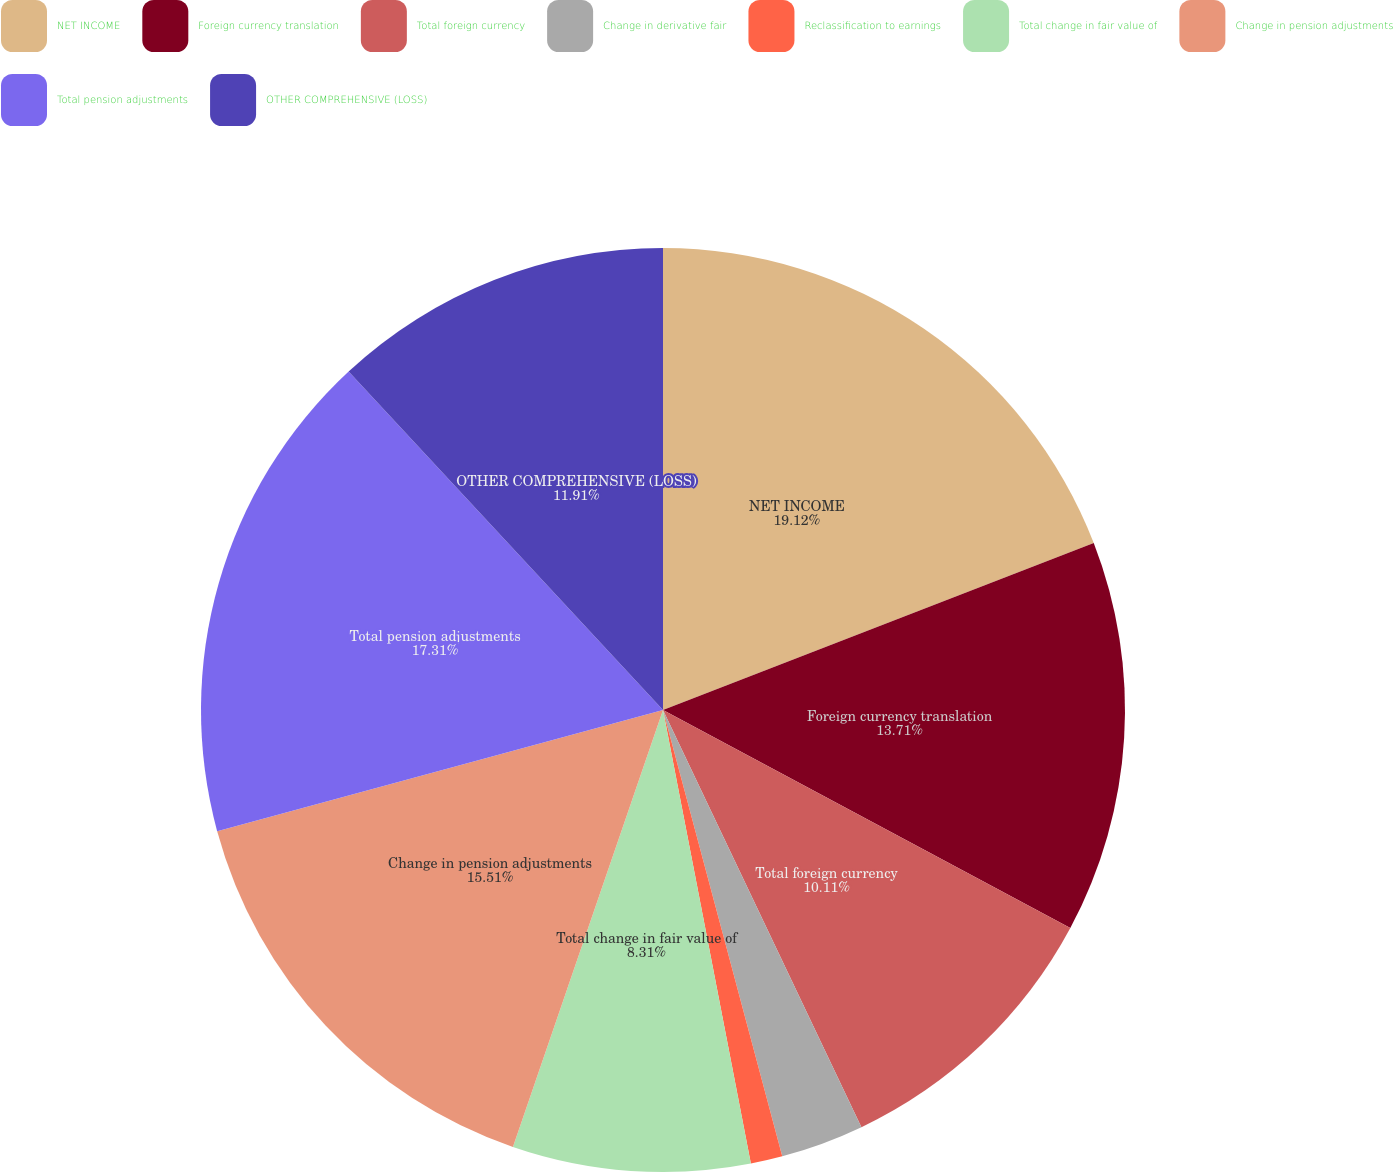Convert chart. <chart><loc_0><loc_0><loc_500><loc_500><pie_chart><fcel>NET INCOME<fcel>Foreign currency translation<fcel>Total foreign currency<fcel>Change in derivative fair<fcel>Reclassification to earnings<fcel>Total change in fair value of<fcel>Change in pension adjustments<fcel>Total pension adjustments<fcel>OTHER COMPREHENSIVE (LOSS)<nl><fcel>19.11%<fcel>13.71%<fcel>10.11%<fcel>2.91%<fcel>1.11%<fcel>8.31%<fcel>15.51%<fcel>17.31%<fcel>11.91%<nl></chart> 